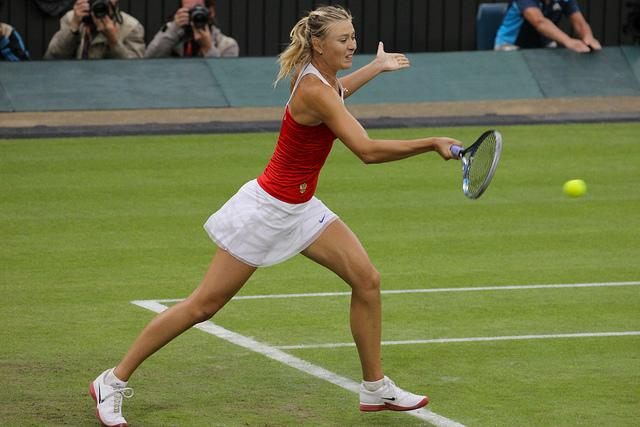What type of shot is the woman hitting?

Choices:
A) slice
B) serve
C) forehand
D) backhand forehand 